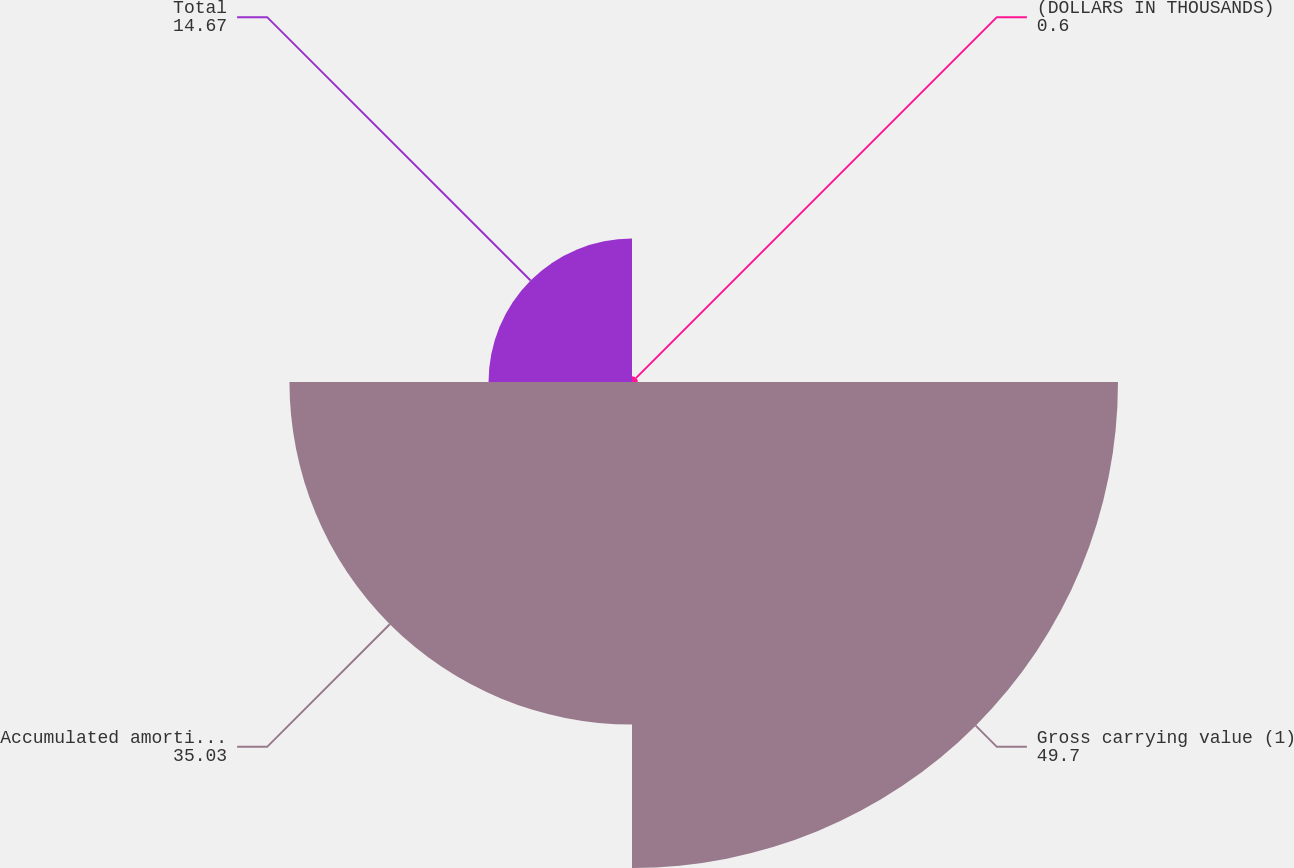Convert chart to OTSL. <chart><loc_0><loc_0><loc_500><loc_500><pie_chart><fcel>(DOLLARS IN THOUSANDS)<fcel>Gross carrying value (1)<fcel>Accumulated amortization<fcel>Total<nl><fcel>0.6%<fcel>49.7%<fcel>35.03%<fcel>14.67%<nl></chart> 